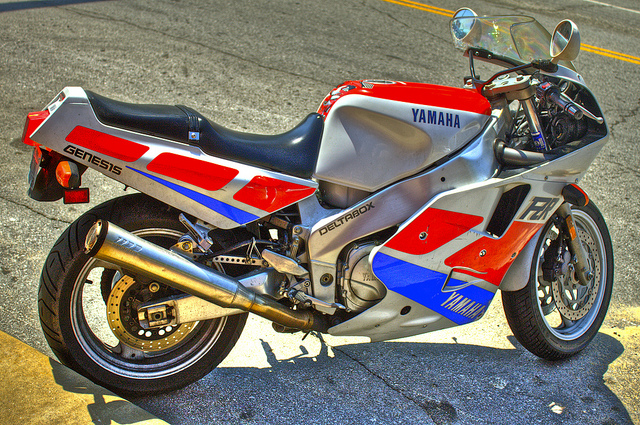Identify the text displayed in this image. YAMAHA DELTABOX YAMAHA GENESIS 